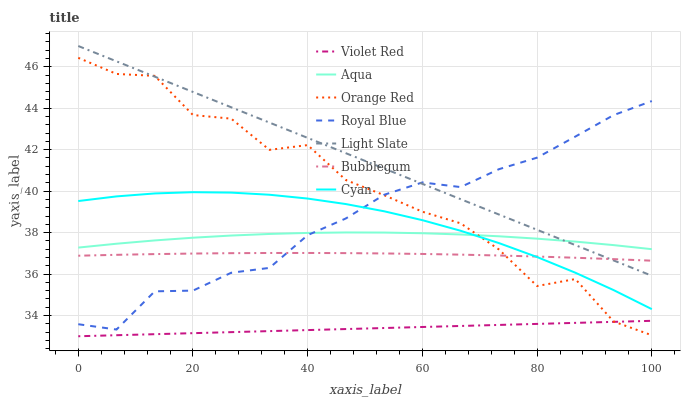Does Violet Red have the minimum area under the curve?
Answer yes or no. Yes. Does Light Slate have the maximum area under the curve?
Answer yes or no. Yes. Does Aqua have the minimum area under the curve?
Answer yes or no. No. Does Aqua have the maximum area under the curve?
Answer yes or no. No. Is Light Slate the smoothest?
Answer yes or no. Yes. Is Orange Red the roughest?
Answer yes or no. Yes. Is Aqua the smoothest?
Answer yes or no. No. Is Aqua the roughest?
Answer yes or no. No. Does Light Slate have the lowest value?
Answer yes or no. No. Does Light Slate have the highest value?
Answer yes or no. Yes. Does Aqua have the highest value?
Answer yes or no. No. Is Violet Red less than Aqua?
Answer yes or no. Yes. Is Light Slate greater than Violet Red?
Answer yes or no. Yes. Does Bubblegum intersect Cyan?
Answer yes or no. Yes. Is Bubblegum less than Cyan?
Answer yes or no. No. Is Bubblegum greater than Cyan?
Answer yes or no. No. Does Violet Red intersect Aqua?
Answer yes or no. No. 